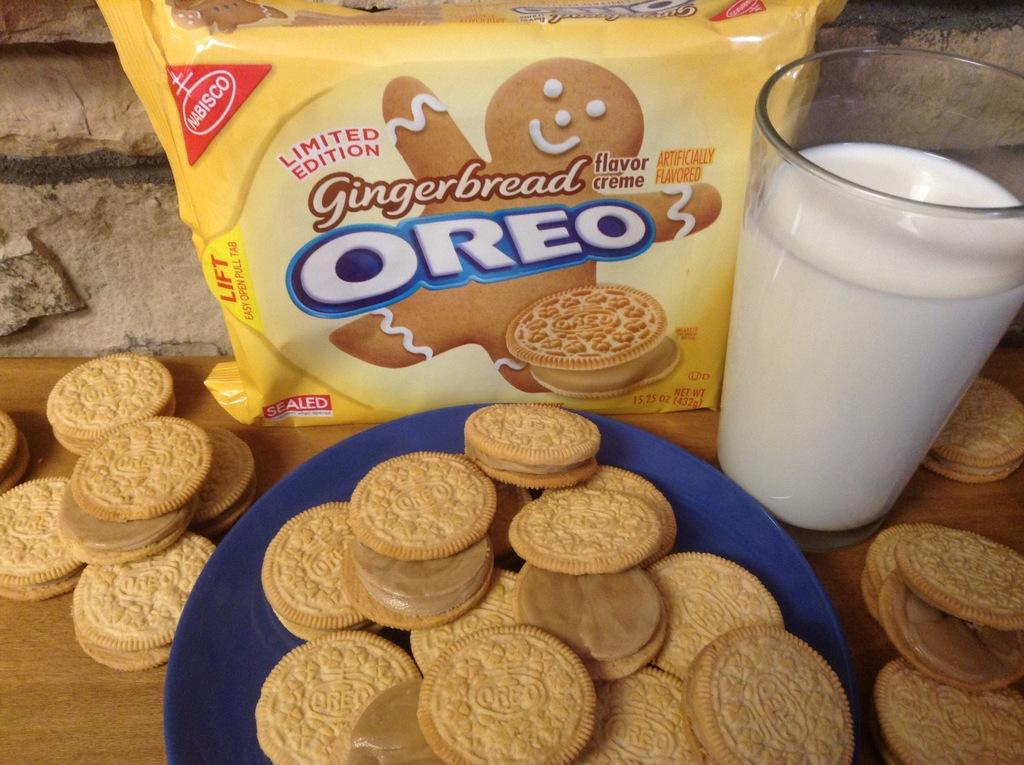What type of food is visible in the image? There are biscuits in the image. What is the biscuits being served with? There is a glass containing milk in the image. Where are the biscuits stored or packaged? There is a biscuit packet in the image. What type of guitar is being played in the image? There is no guitar present in the image; it features biscuits and milk. 